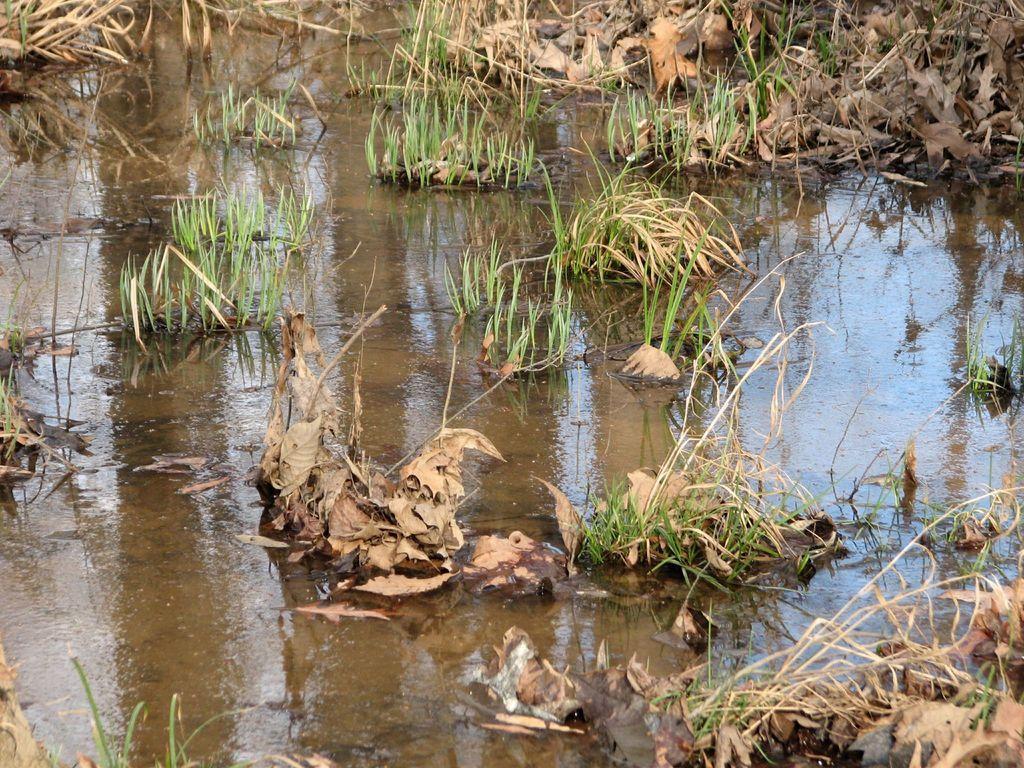How would you summarize this image in a sentence or two? In this image I can see water and grass. 